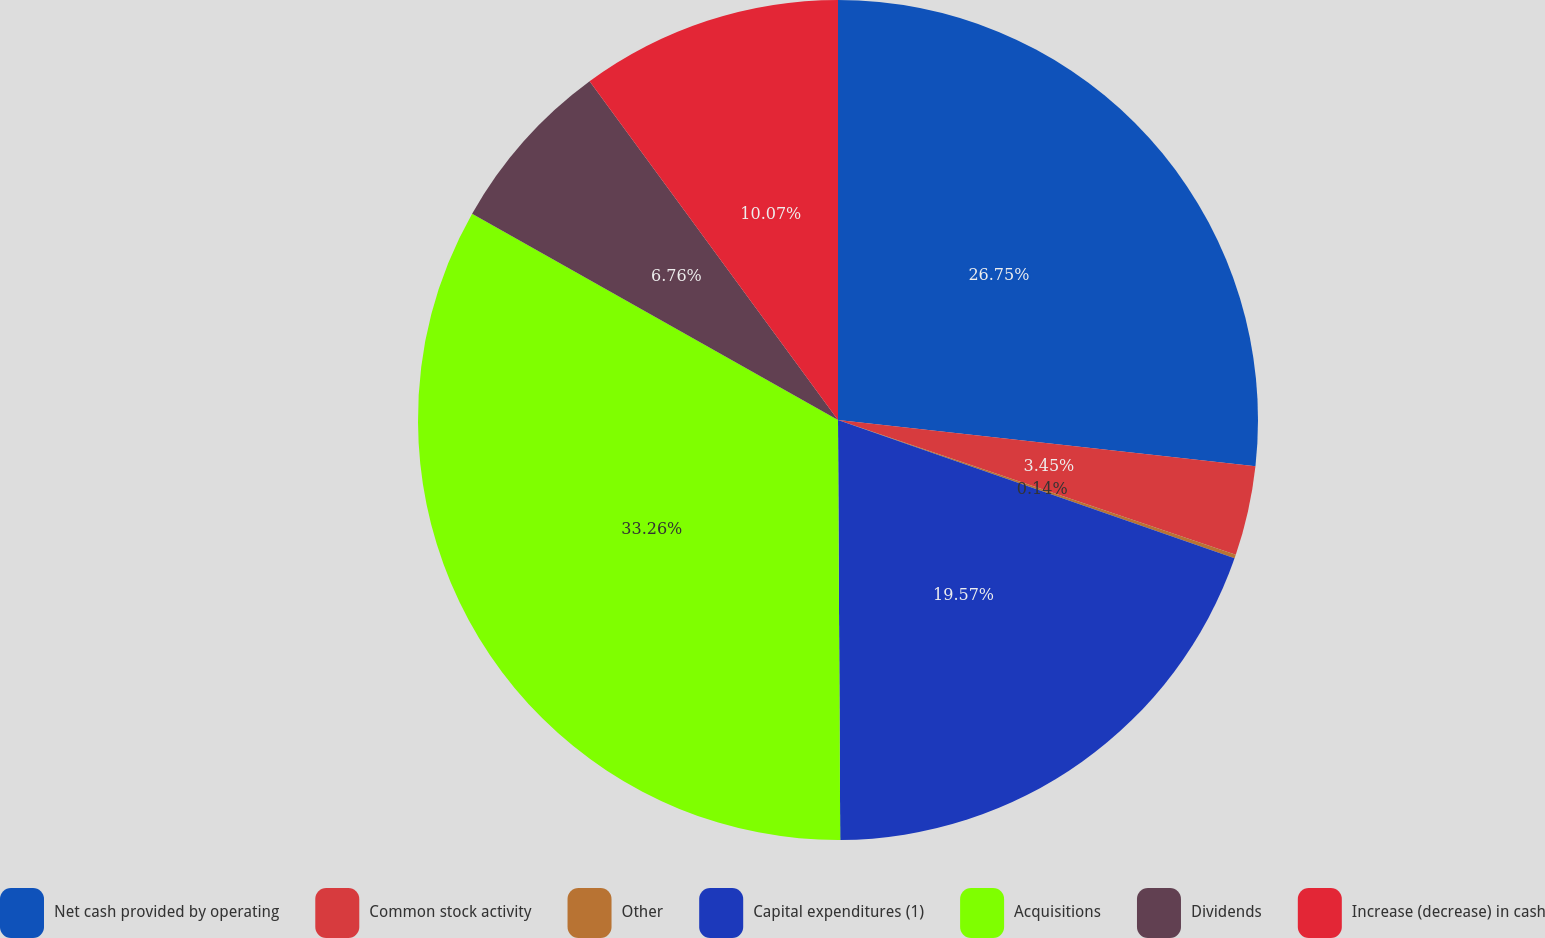<chart> <loc_0><loc_0><loc_500><loc_500><pie_chart><fcel>Net cash provided by operating<fcel>Common stock activity<fcel>Other<fcel>Capital expenditures (1)<fcel>Acquisitions<fcel>Dividends<fcel>Increase (decrease) in cash<nl><fcel>26.75%<fcel>3.45%<fcel>0.14%<fcel>19.57%<fcel>33.25%<fcel>6.76%<fcel>10.07%<nl></chart> 